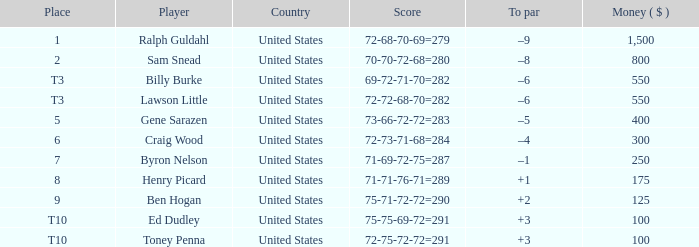Which nation has an award less than $250 and the participant henry picard? United States. 